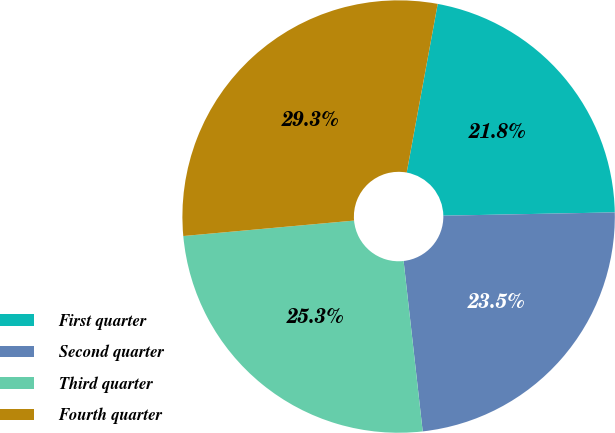<chart> <loc_0><loc_0><loc_500><loc_500><pie_chart><fcel>First quarter<fcel>Second quarter<fcel>Third quarter<fcel>Fourth quarter<nl><fcel>21.8%<fcel>23.53%<fcel>25.34%<fcel>29.33%<nl></chart> 